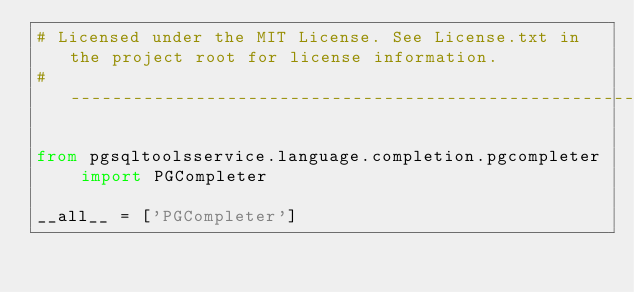Convert code to text. <code><loc_0><loc_0><loc_500><loc_500><_Python_># Licensed under the MIT License. See License.txt in the project root for license information.
# --------------------------------------------------------------------------------------------

from pgsqltoolsservice.language.completion.pgcompleter import PGCompleter

__all__ = ['PGCompleter']
</code> 